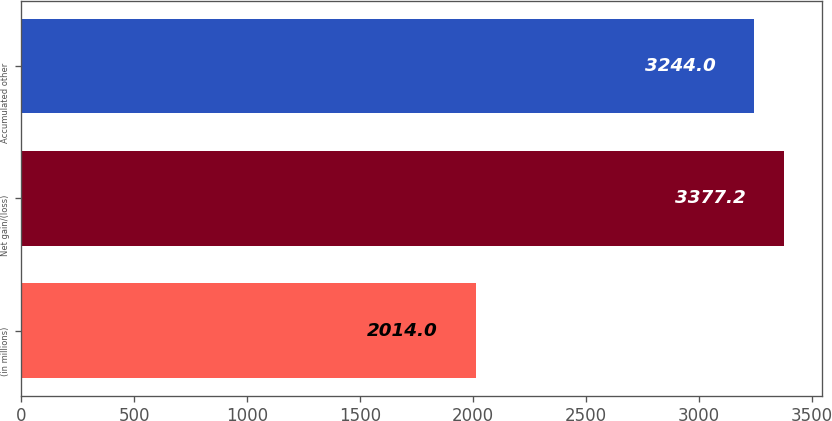Convert chart to OTSL. <chart><loc_0><loc_0><loc_500><loc_500><bar_chart><fcel>(in millions)<fcel>Net gain/(loss)<fcel>Accumulated other<nl><fcel>2014<fcel>3377.2<fcel>3244<nl></chart> 